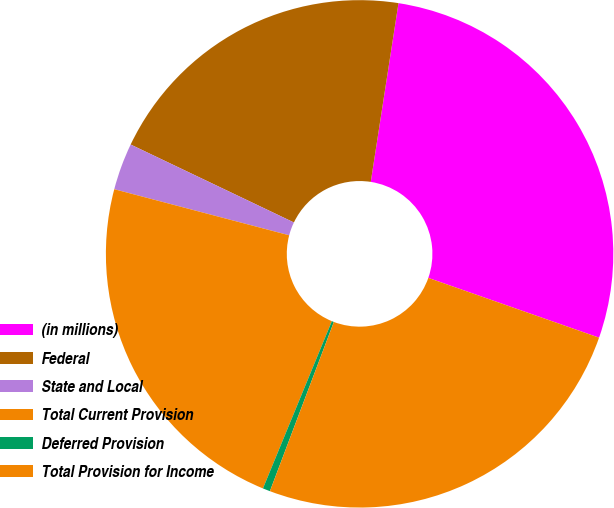Convert chart to OTSL. <chart><loc_0><loc_0><loc_500><loc_500><pie_chart><fcel>(in millions)<fcel>Federal<fcel>State and Local<fcel>Total Current Provision<fcel>Deferred Provision<fcel>Total Provision for Income<nl><fcel>27.91%<fcel>20.36%<fcel>2.99%<fcel>22.88%<fcel>0.47%<fcel>25.39%<nl></chart> 